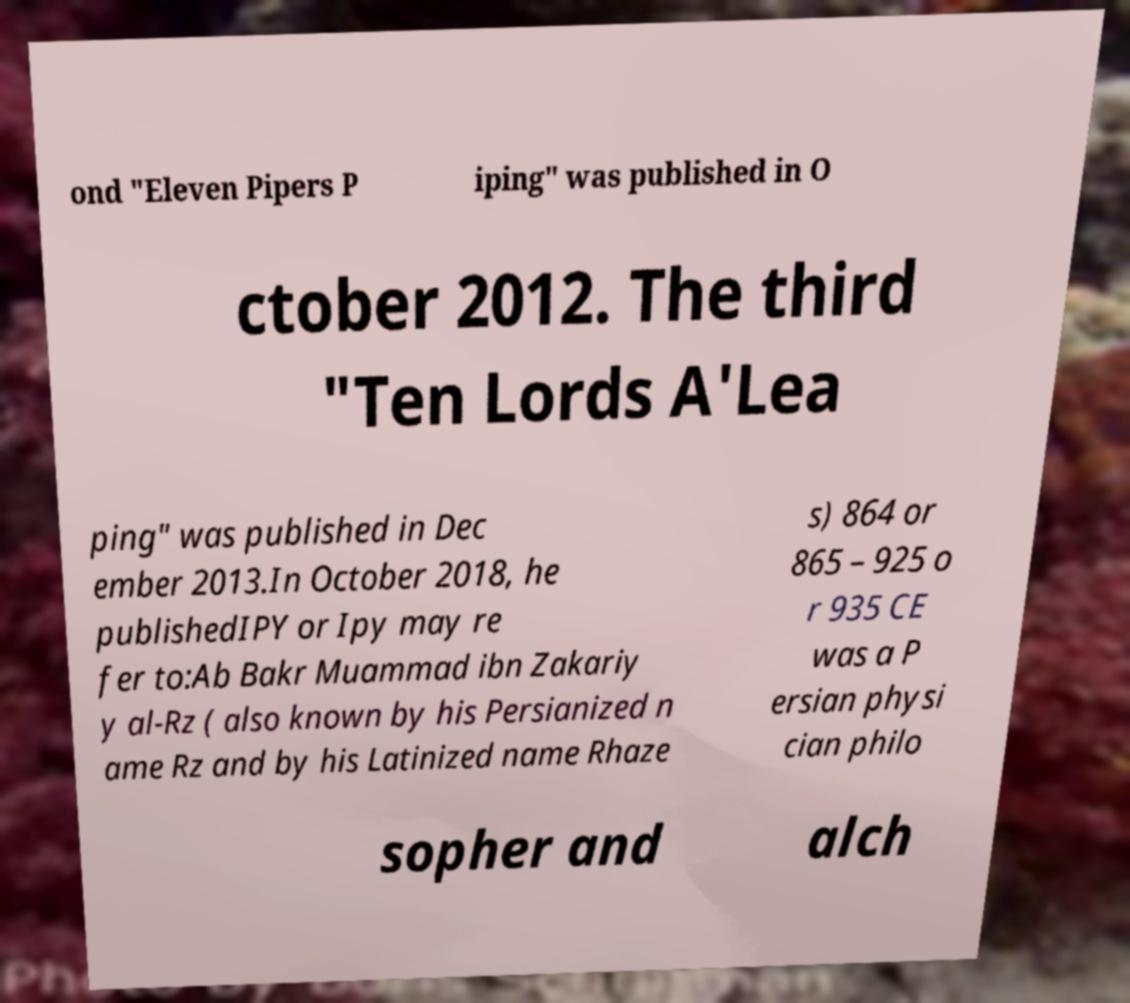Please read and relay the text visible in this image. What does it say? ond "Eleven Pipers P iping" was published in O ctober 2012. The third "Ten Lords A'Lea ping" was published in Dec ember 2013.In October 2018, he publishedIPY or Ipy may re fer to:Ab Bakr Muammad ibn Zakariy y al-Rz ( also known by his Persianized n ame Rz and by his Latinized name Rhaze s) 864 or 865 – 925 o r 935 CE was a P ersian physi cian philo sopher and alch 